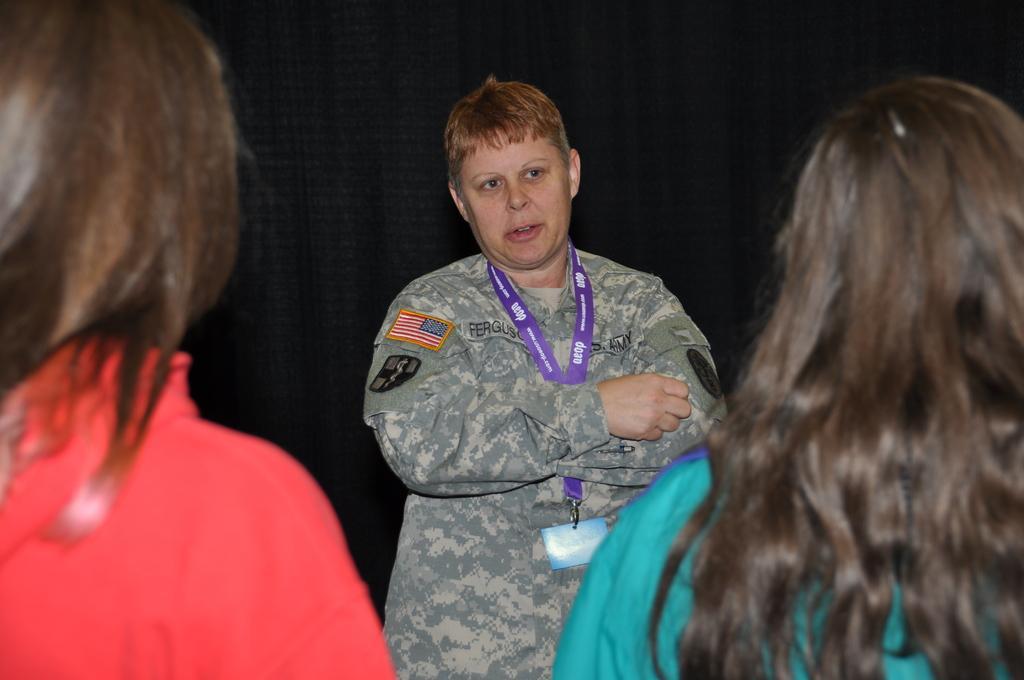Please provide a concise description of this image. In this image I can see there are three women, one in the background and two in the foreground of the image. There is a black surface in the background. 